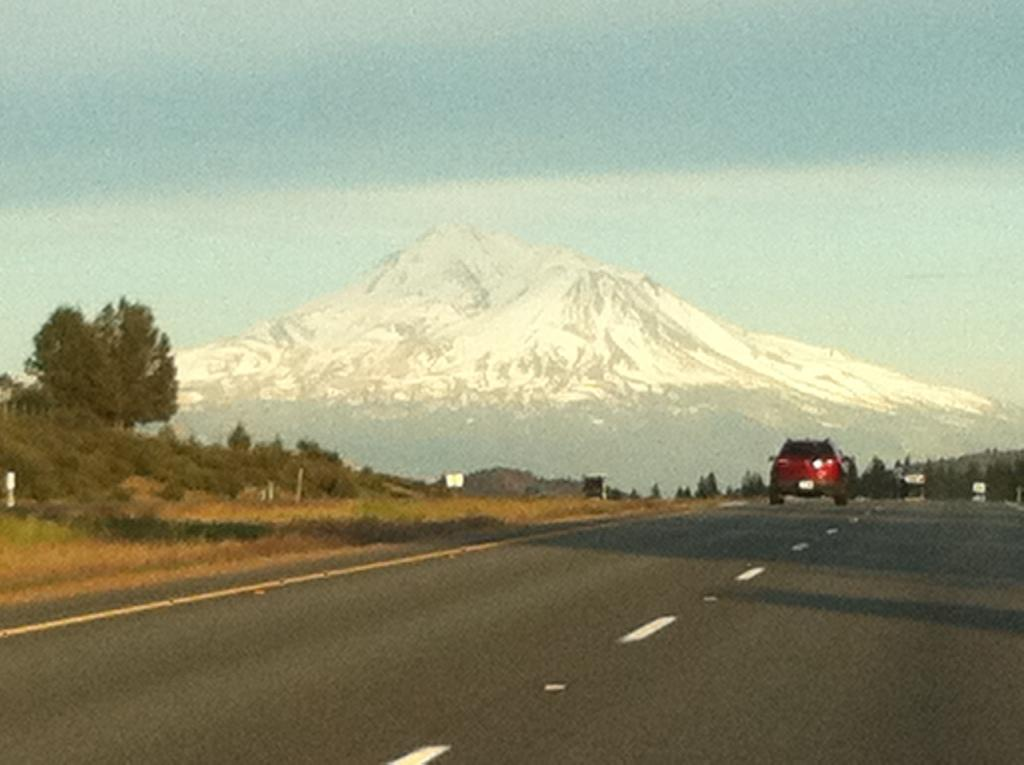What is the main subject of the image? There is a car on the road in the image. What can be seen on the left side of the image? There are trees on the left side of the image. What is visible in the background of the image? Hills and the sky are visible in the background of the image. Where is the hospital located in the image? There is no hospital present in the image. How many frogs can be seen hopping on the car in the image? There are no frogs visible in the image; it features a car on the road with trees on the left side and hills and sky in the background. 